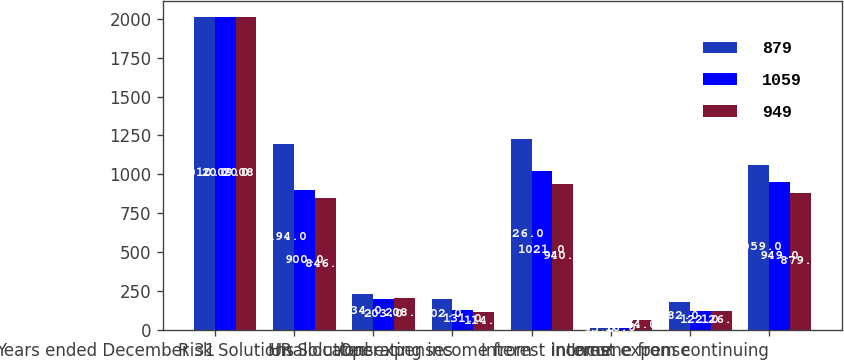Convert chart. <chart><loc_0><loc_0><loc_500><loc_500><stacked_bar_chart><ecel><fcel>Years ended December 31<fcel>Risk Solutions<fcel>HR Solutions<fcel>Unallocated expenses<fcel>Operating income from<fcel>Interest income<fcel>Interest expense<fcel>Income from continuing<nl><fcel>879<fcel>2010<fcel>1194<fcel>234<fcel>202<fcel>1226<fcel>15<fcel>182<fcel>1059<nl><fcel>1059<fcel>2009<fcel>900<fcel>203<fcel>131<fcel>1021<fcel>16<fcel>122<fcel>949<nl><fcel>949<fcel>2008<fcel>846<fcel>208<fcel>114<fcel>940<fcel>64<fcel>126<fcel>879<nl></chart> 